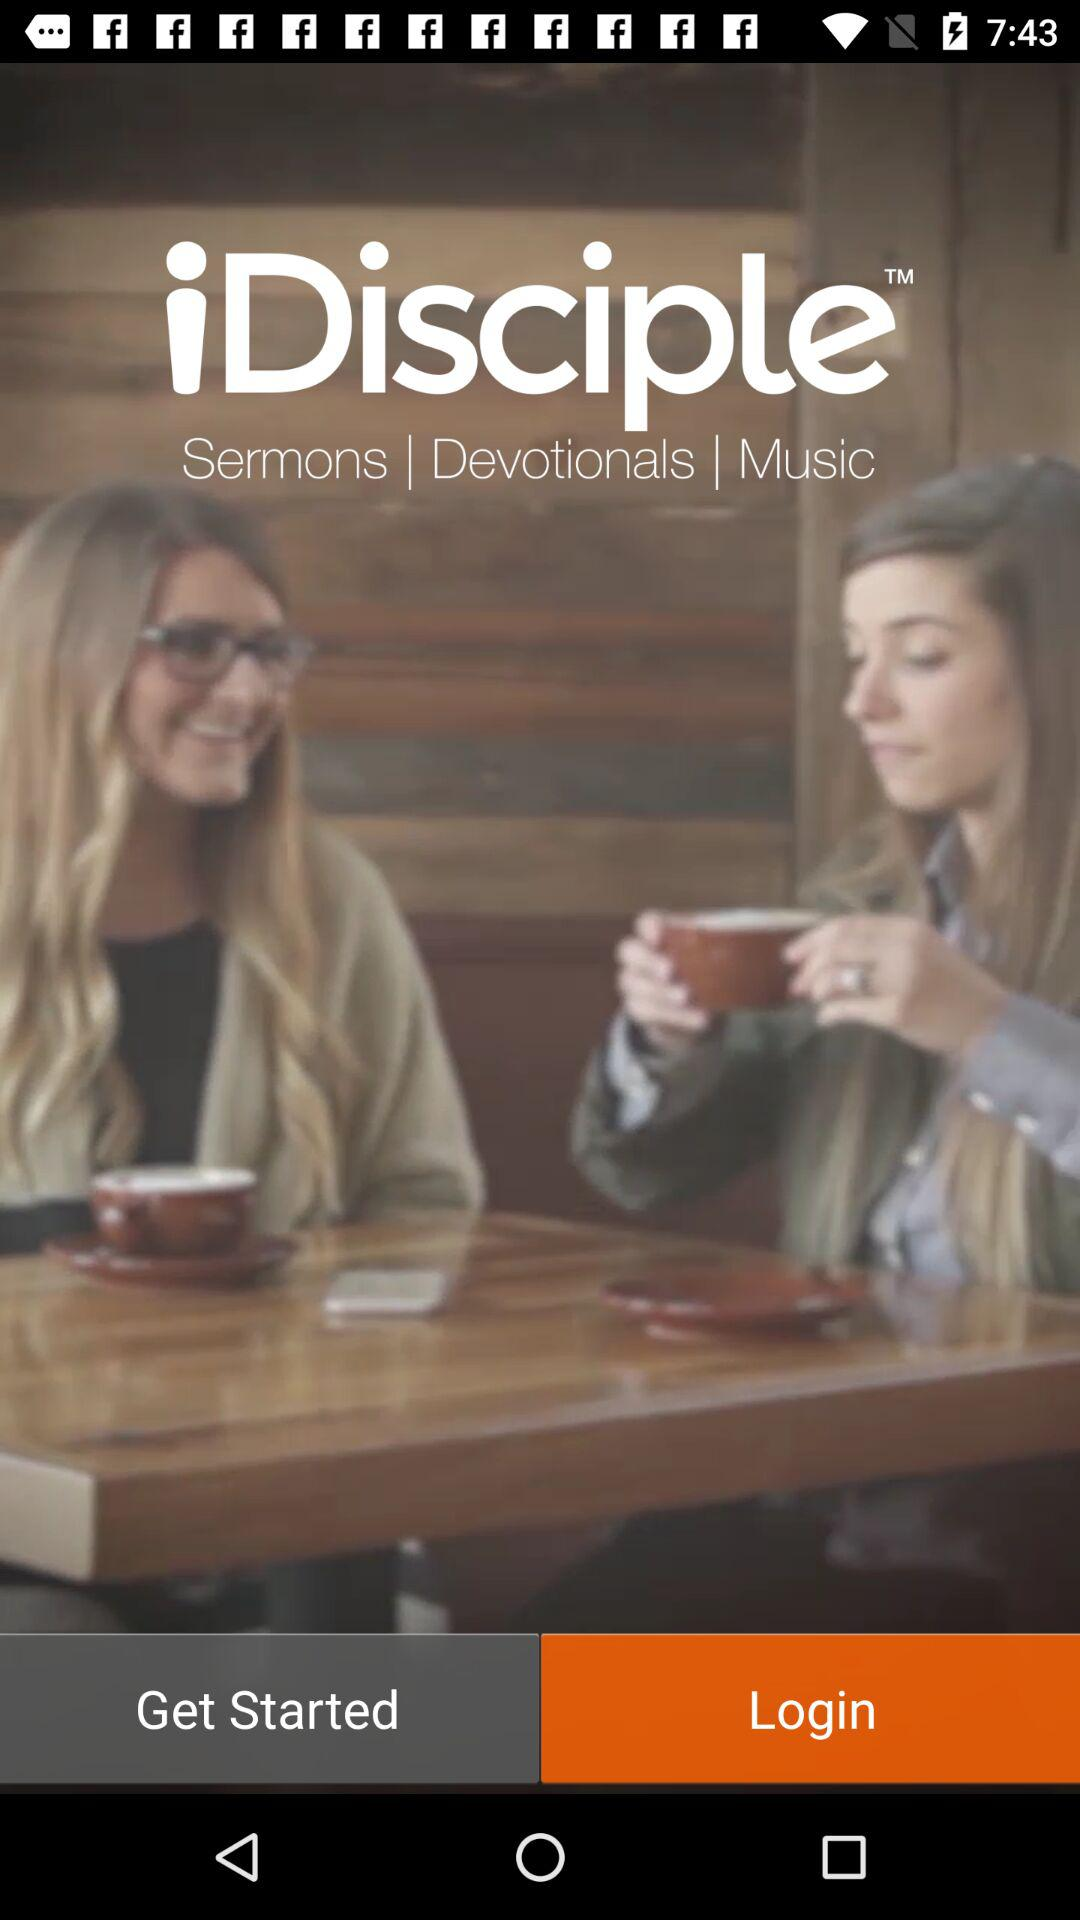What is the application name? The application name is "iDisciple". 